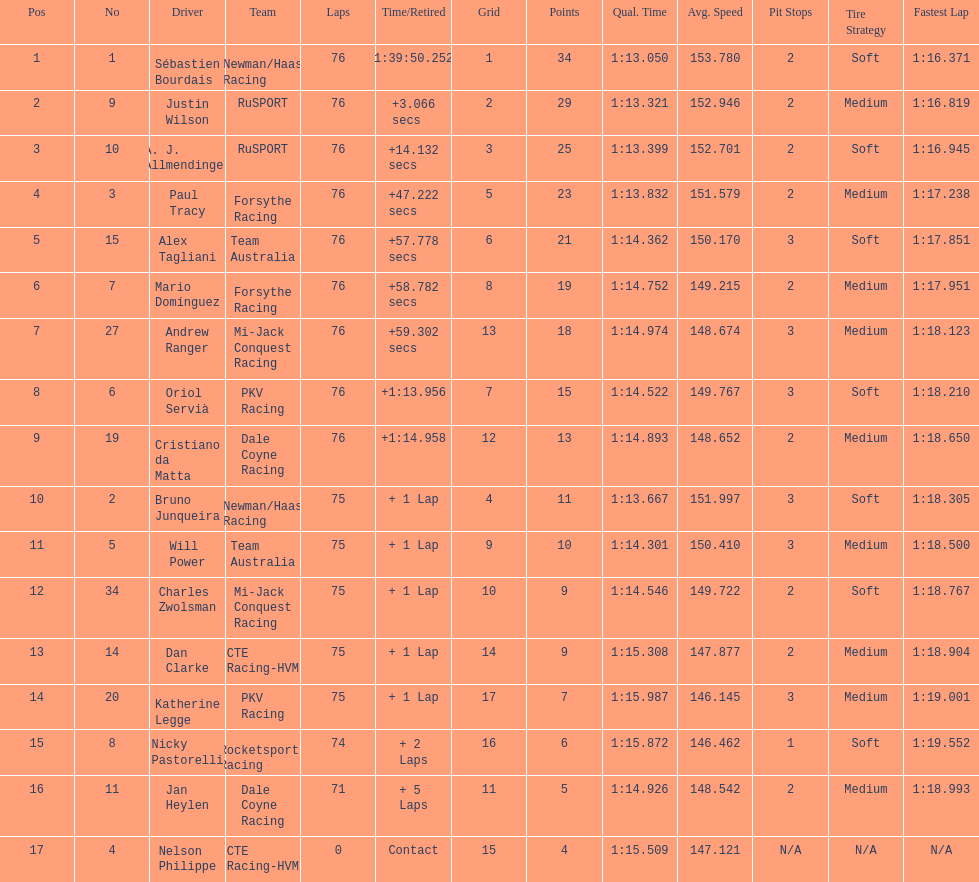Charles zwolsman acquired the same number of points as who? Dan Clarke. 